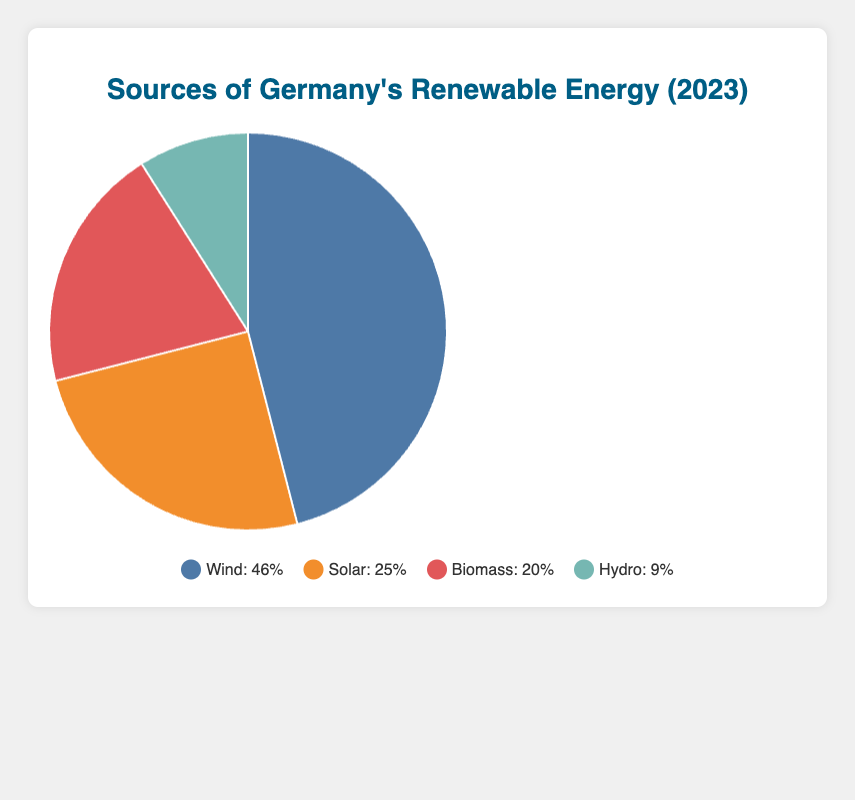How much larger is the percentage of energy from wind compared to solar? Wind contributes 46.0%, while solar contributes 25.0%. The difference is calculated as 46.0% - 25.0%.
Answer: 21.0% What is the combined contribution of biomass and hydro energy sources? Biomass contributes 20.0% and hydro contributes 9.0%. The sum of their contributions is 20.0% + 9.0%.
Answer: 29.0% Which renewable energy type has the lowest contribution, and what is it? By comparing percentages, Wind (46.0%), Solar (25.0%), Biomass (20.0%), and Hydro (9.0%), Hydro has the lowest contribution.
Answer: Hydro, 9.0% What is the total percentage of renewable energy provided by solar and biomass combined? Solar contributes 25.0% and biomass contributes 20.0%. Their combined contribution is 25.0% + 20.0%.
Answer: 45.0% What is the average percentage contribution of all four renewable energy types? Summing the contributions (46.0% + 25.0% + 20.0% + 9.0%) gives 100.0%. Dividing by four types, the average is 100.0% / 4.
Answer: 25.0% Which renewable energy type has more than double the contribution of hydro, and by how much? Hydro contributes 9.0%, so more than double is more than 18.0%. Both Wind (46.0%) and Solar (25.0%) exceed this. Wind exceeds hydro by 37.0% (46.0% - 9.0%), and Solar exceeds hydro by 16.0% (25.0% - 9.0%).
Answer: Wind, 37.0%; Solar, 16.0% How does the contribution of offshore wind farms compare to that of solid biomass? Offshore wind farms contribute 10.0%, while solid biomass contributes 5.0%. Offshore wind farms contribute twice as much as solid biomass.
Answer: Offshore wind farms, twice as much What is the remaining percentage of renewable energy, excluding wind? Excluding wind (46.0%), the remaining types contribute Solar (25.0%) + Biomass (20.0%) + Hydro (9.0%). The total is 25.0% + 20.0% + 9.0%.
Answer: 54.0% How much does biogas contribute to the overall biomass energy? Biogas plants contribute 12.0% out of the total biomass contribution of 20.0%.
Answer: 12.0% of 20.0% What color represents solar energy in the pie chart? The color used for solar energy in the chart is orange.
Answer: Orange 